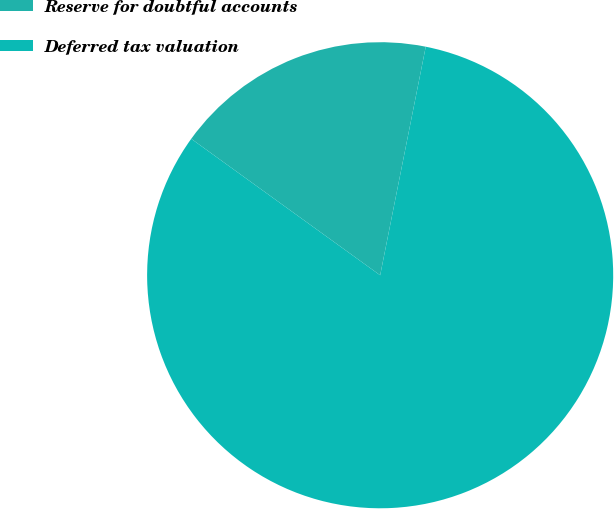<chart> <loc_0><loc_0><loc_500><loc_500><pie_chart><fcel>Reserve for doubtful accounts<fcel>Deferred tax valuation<nl><fcel>18.18%<fcel>81.82%<nl></chart> 